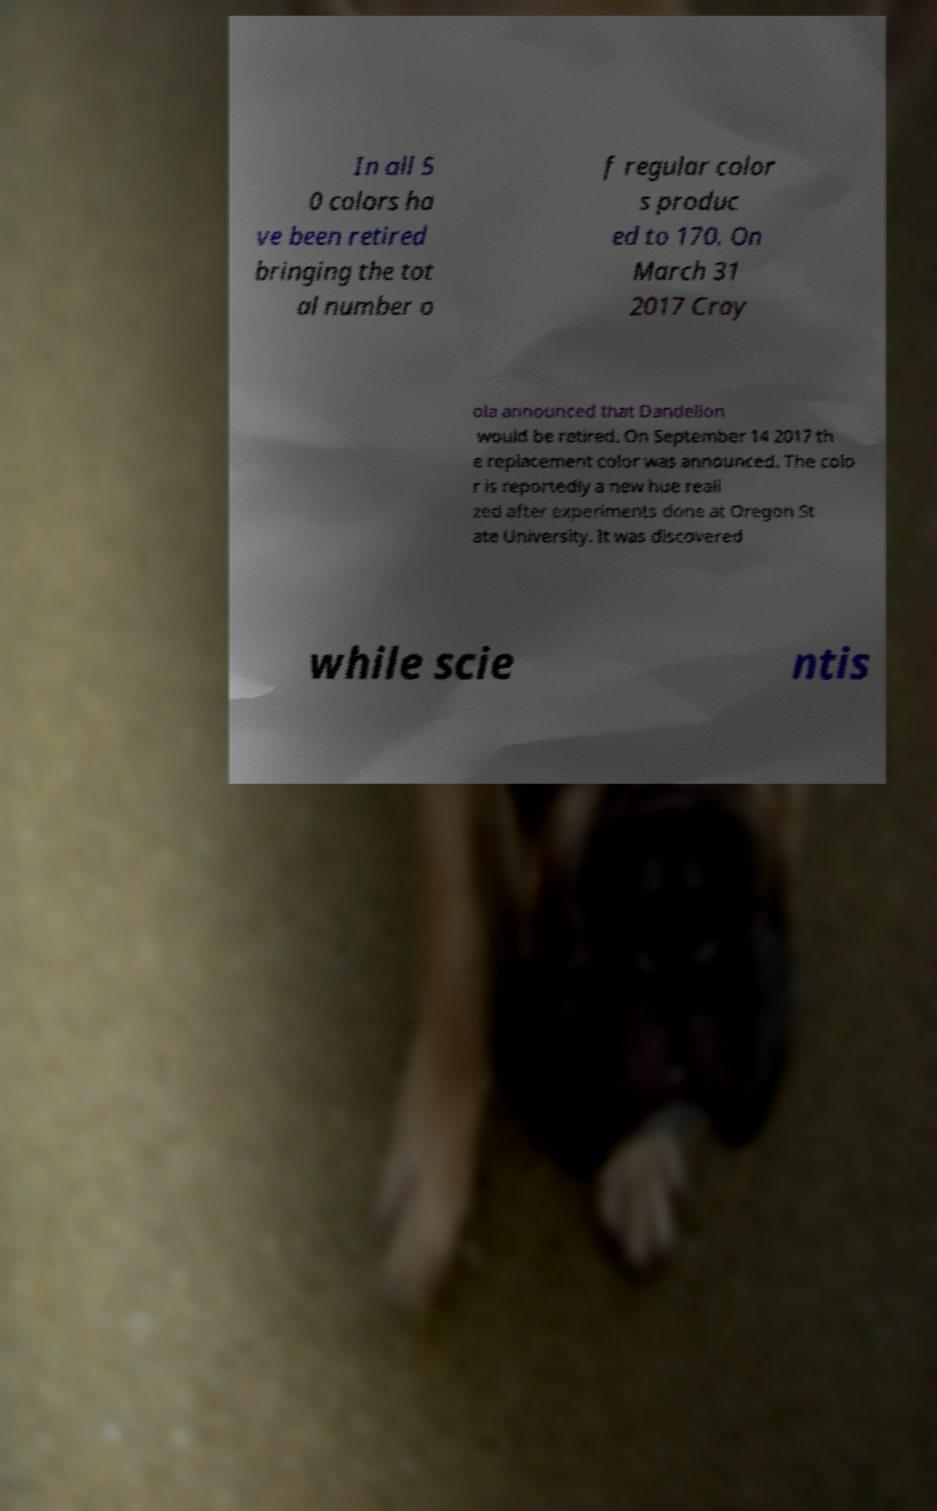Can you read and provide the text displayed in the image?This photo seems to have some interesting text. Can you extract and type it out for me? In all 5 0 colors ha ve been retired bringing the tot al number o f regular color s produc ed to 170. On March 31 2017 Cray ola announced that Dandelion would be retired. On September 14 2017 th e replacement color was announced. The colo r is reportedly a new hue reali zed after experiments done at Oregon St ate University. It was discovered while scie ntis 